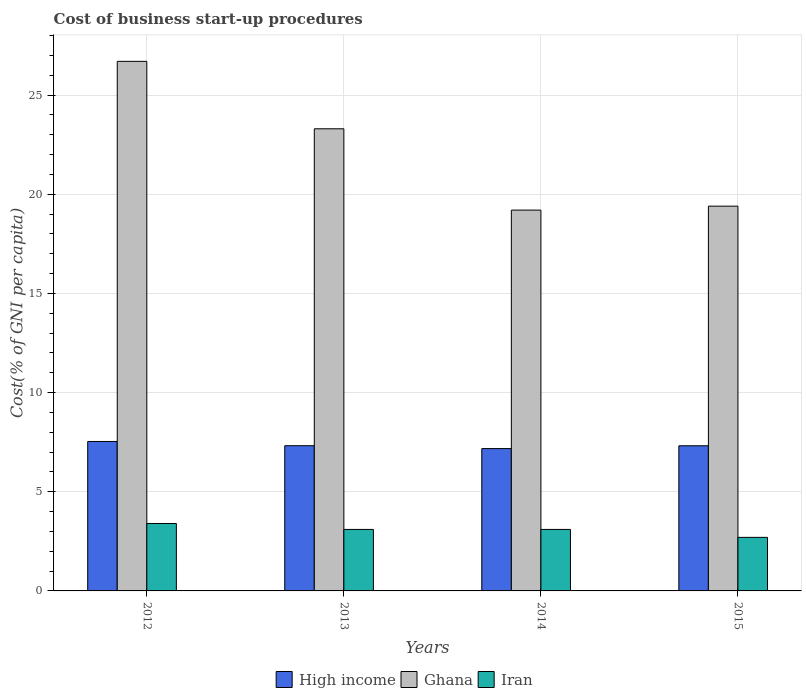How many groups of bars are there?
Offer a terse response. 4. Are the number of bars per tick equal to the number of legend labels?
Provide a short and direct response. Yes. Are the number of bars on each tick of the X-axis equal?
Provide a short and direct response. Yes. How many bars are there on the 3rd tick from the right?
Provide a succinct answer. 3. In how many cases, is the number of bars for a given year not equal to the number of legend labels?
Make the answer very short. 0. Across all years, what is the maximum cost of business start-up procedures in Ghana?
Make the answer very short. 26.7. Across all years, what is the minimum cost of business start-up procedures in Ghana?
Provide a succinct answer. 19.2. In which year was the cost of business start-up procedures in Iran minimum?
Provide a short and direct response. 2015. What is the total cost of business start-up procedures in High income in the graph?
Make the answer very short. 29.35. What is the difference between the cost of business start-up procedures in Iran in 2012 and that in 2013?
Offer a very short reply. 0.3. What is the difference between the cost of business start-up procedures in Iran in 2015 and the cost of business start-up procedures in High income in 2013?
Your answer should be very brief. -4.62. What is the average cost of business start-up procedures in High income per year?
Offer a very short reply. 7.34. In the year 2012, what is the difference between the cost of business start-up procedures in High income and cost of business start-up procedures in Iran?
Provide a succinct answer. 4.14. In how many years, is the cost of business start-up procedures in High income greater than 18 %?
Offer a very short reply. 0. What is the ratio of the cost of business start-up procedures in High income in 2014 to that in 2015?
Provide a succinct answer. 0.98. Is the difference between the cost of business start-up procedures in High income in 2012 and 2013 greater than the difference between the cost of business start-up procedures in Iran in 2012 and 2013?
Ensure brevity in your answer.  No. What is the difference between the highest and the second highest cost of business start-up procedures in High income?
Make the answer very short. 0.21. What is the difference between the highest and the lowest cost of business start-up procedures in Iran?
Your response must be concise. 0.7. Is the sum of the cost of business start-up procedures in Iran in 2014 and 2015 greater than the maximum cost of business start-up procedures in High income across all years?
Offer a very short reply. No. What does the 2nd bar from the left in 2012 represents?
Keep it short and to the point. Ghana. What does the 3rd bar from the right in 2012 represents?
Make the answer very short. High income. Are the values on the major ticks of Y-axis written in scientific E-notation?
Ensure brevity in your answer.  No. Does the graph contain any zero values?
Ensure brevity in your answer.  No. Does the graph contain grids?
Ensure brevity in your answer.  Yes. Where does the legend appear in the graph?
Offer a terse response. Bottom center. How are the legend labels stacked?
Give a very brief answer. Horizontal. What is the title of the graph?
Your response must be concise. Cost of business start-up procedures. Does "Dominican Republic" appear as one of the legend labels in the graph?
Your response must be concise. No. What is the label or title of the Y-axis?
Make the answer very short. Cost(% of GNI per capita). What is the Cost(% of GNI per capita) of High income in 2012?
Your answer should be compact. 7.54. What is the Cost(% of GNI per capita) in Ghana in 2012?
Offer a very short reply. 26.7. What is the Cost(% of GNI per capita) of High income in 2013?
Make the answer very short. 7.32. What is the Cost(% of GNI per capita) in Ghana in 2013?
Offer a terse response. 23.3. What is the Cost(% of GNI per capita) in Iran in 2013?
Ensure brevity in your answer.  3.1. What is the Cost(% of GNI per capita) of High income in 2014?
Provide a succinct answer. 7.18. What is the Cost(% of GNI per capita) in Ghana in 2014?
Provide a succinct answer. 19.2. What is the Cost(% of GNI per capita) of High income in 2015?
Your answer should be compact. 7.32. What is the Cost(% of GNI per capita) in Ghana in 2015?
Your answer should be compact. 19.4. Across all years, what is the maximum Cost(% of GNI per capita) of High income?
Provide a short and direct response. 7.54. Across all years, what is the maximum Cost(% of GNI per capita) of Ghana?
Give a very brief answer. 26.7. Across all years, what is the minimum Cost(% of GNI per capita) of High income?
Make the answer very short. 7.18. What is the total Cost(% of GNI per capita) of High income in the graph?
Keep it short and to the point. 29.35. What is the total Cost(% of GNI per capita) of Ghana in the graph?
Ensure brevity in your answer.  88.6. What is the total Cost(% of GNI per capita) in Iran in the graph?
Offer a very short reply. 12.3. What is the difference between the Cost(% of GNI per capita) in High income in 2012 and that in 2013?
Your answer should be compact. 0.21. What is the difference between the Cost(% of GNI per capita) in Ghana in 2012 and that in 2013?
Provide a short and direct response. 3.4. What is the difference between the Cost(% of GNI per capita) of High income in 2012 and that in 2014?
Provide a short and direct response. 0.36. What is the difference between the Cost(% of GNI per capita) of Ghana in 2012 and that in 2014?
Your response must be concise. 7.5. What is the difference between the Cost(% of GNI per capita) in High income in 2012 and that in 2015?
Your answer should be very brief. 0.22. What is the difference between the Cost(% of GNI per capita) in Ghana in 2012 and that in 2015?
Ensure brevity in your answer.  7.3. What is the difference between the Cost(% of GNI per capita) in High income in 2013 and that in 2014?
Your response must be concise. 0.14. What is the difference between the Cost(% of GNI per capita) in Iran in 2013 and that in 2014?
Provide a short and direct response. 0. What is the difference between the Cost(% of GNI per capita) of High income in 2013 and that in 2015?
Ensure brevity in your answer.  0. What is the difference between the Cost(% of GNI per capita) in Iran in 2013 and that in 2015?
Provide a succinct answer. 0.4. What is the difference between the Cost(% of GNI per capita) of High income in 2014 and that in 2015?
Provide a succinct answer. -0.14. What is the difference between the Cost(% of GNI per capita) in Iran in 2014 and that in 2015?
Keep it short and to the point. 0.4. What is the difference between the Cost(% of GNI per capita) in High income in 2012 and the Cost(% of GNI per capita) in Ghana in 2013?
Make the answer very short. -15.76. What is the difference between the Cost(% of GNI per capita) of High income in 2012 and the Cost(% of GNI per capita) of Iran in 2013?
Your answer should be compact. 4.44. What is the difference between the Cost(% of GNI per capita) in Ghana in 2012 and the Cost(% of GNI per capita) in Iran in 2013?
Keep it short and to the point. 23.6. What is the difference between the Cost(% of GNI per capita) of High income in 2012 and the Cost(% of GNI per capita) of Ghana in 2014?
Ensure brevity in your answer.  -11.66. What is the difference between the Cost(% of GNI per capita) of High income in 2012 and the Cost(% of GNI per capita) of Iran in 2014?
Offer a very short reply. 4.44. What is the difference between the Cost(% of GNI per capita) in Ghana in 2012 and the Cost(% of GNI per capita) in Iran in 2014?
Give a very brief answer. 23.6. What is the difference between the Cost(% of GNI per capita) of High income in 2012 and the Cost(% of GNI per capita) of Ghana in 2015?
Your answer should be very brief. -11.86. What is the difference between the Cost(% of GNI per capita) in High income in 2012 and the Cost(% of GNI per capita) in Iran in 2015?
Make the answer very short. 4.84. What is the difference between the Cost(% of GNI per capita) of Ghana in 2012 and the Cost(% of GNI per capita) of Iran in 2015?
Your answer should be very brief. 24. What is the difference between the Cost(% of GNI per capita) in High income in 2013 and the Cost(% of GNI per capita) in Ghana in 2014?
Provide a short and direct response. -11.88. What is the difference between the Cost(% of GNI per capita) of High income in 2013 and the Cost(% of GNI per capita) of Iran in 2014?
Give a very brief answer. 4.22. What is the difference between the Cost(% of GNI per capita) in Ghana in 2013 and the Cost(% of GNI per capita) in Iran in 2014?
Ensure brevity in your answer.  20.2. What is the difference between the Cost(% of GNI per capita) of High income in 2013 and the Cost(% of GNI per capita) of Ghana in 2015?
Your answer should be very brief. -12.08. What is the difference between the Cost(% of GNI per capita) of High income in 2013 and the Cost(% of GNI per capita) of Iran in 2015?
Offer a very short reply. 4.62. What is the difference between the Cost(% of GNI per capita) of Ghana in 2013 and the Cost(% of GNI per capita) of Iran in 2015?
Your answer should be very brief. 20.6. What is the difference between the Cost(% of GNI per capita) in High income in 2014 and the Cost(% of GNI per capita) in Ghana in 2015?
Offer a terse response. -12.22. What is the difference between the Cost(% of GNI per capita) of High income in 2014 and the Cost(% of GNI per capita) of Iran in 2015?
Offer a terse response. 4.48. What is the difference between the Cost(% of GNI per capita) of Ghana in 2014 and the Cost(% of GNI per capita) of Iran in 2015?
Your response must be concise. 16.5. What is the average Cost(% of GNI per capita) in High income per year?
Give a very brief answer. 7.34. What is the average Cost(% of GNI per capita) in Ghana per year?
Provide a short and direct response. 22.15. What is the average Cost(% of GNI per capita) in Iran per year?
Give a very brief answer. 3.08. In the year 2012, what is the difference between the Cost(% of GNI per capita) of High income and Cost(% of GNI per capita) of Ghana?
Your answer should be compact. -19.16. In the year 2012, what is the difference between the Cost(% of GNI per capita) of High income and Cost(% of GNI per capita) of Iran?
Ensure brevity in your answer.  4.14. In the year 2012, what is the difference between the Cost(% of GNI per capita) in Ghana and Cost(% of GNI per capita) in Iran?
Give a very brief answer. 23.3. In the year 2013, what is the difference between the Cost(% of GNI per capita) of High income and Cost(% of GNI per capita) of Ghana?
Provide a succinct answer. -15.98. In the year 2013, what is the difference between the Cost(% of GNI per capita) in High income and Cost(% of GNI per capita) in Iran?
Your answer should be very brief. 4.22. In the year 2013, what is the difference between the Cost(% of GNI per capita) of Ghana and Cost(% of GNI per capita) of Iran?
Your response must be concise. 20.2. In the year 2014, what is the difference between the Cost(% of GNI per capita) in High income and Cost(% of GNI per capita) in Ghana?
Give a very brief answer. -12.02. In the year 2014, what is the difference between the Cost(% of GNI per capita) in High income and Cost(% of GNI per capita) in Iran?
Ensure brevity in your answer.  4.08. In the year 2014, what is the difference between the Cost(% of GNI per capita) of Ghana and Cost(% of GNI per capita) of Iran?
Offer a terse response. 16.1. In the year 2015, what is the difference between the Cost(% of GNI per capita) of High income and Cost(% of GNI per capita) of Ghana?
Offer a very short reply. -12.08. In the year 2015, what is the difference between the Cost(% of GNI per capita) in High income and Cost(% of GNI per capita) in Iran?
Provide a short and direct response. 4.62. In the year 2015, what is the difference between the Cost(% of GNI per capita) of Ghana and Cost(% of GNI per capita) of Iran?
Offer a terse response. 16.7. What is the ratio of the Cost(% of GNI per capita) in High income in 2012 to that in 2013?
Offer a terse response. 1.03. What is the ratio of the Cost(% of GNI per capita) in Ghana in 2012 to that in 2013?
Your answer should be very brief. 1.15. What is the ratio of the Cost(% of GNI per capita) in Iran in 2012 to that in 2013?
Your answer should be very brief. 1.1. What is the ratio of the Cost(% of GNI per capita) in High income in 2012 to that in 2014?
Offer a very short reply. 1.05. What is the ratio of the Cost(% of GNI per capita) in Ghana in 2012 to that in 2014?
Give a very brief answer. 1.39. What is the ratio of the Cost(% of GNI per capita) in Iran in 2012 to that in 2014?
Make the answer very short. 1.1. What is the ratio of the Cost(% of GNI per capita) of High income in 2012 to that in 2015?
Ensure brevity in your answer.  1.03. What is the ratio of the Cost(% of GNI per capita) in Ghana in 2012 to that in 2015?
Keep it short and to the point. 1.38. What is the ratio of the Cost(% of GNI per capita) of Iran in 2012 to that in 2015?
Provide a short and direct response. 1.26. What is the ratio of the Cost(% of GNI per capita) of High income in 2013 to that in 2014?
Your response must be concise. 1.02. What is the ratio of the Cost(% of GNI per capita) in Ghana in 2013 to that in 2014?
Provide a short and direct response. 1.21. What is the ratio of the Cost(% of GNI per capita) in High income in 2013 to that in 2015?
Give a very brief answer. 1. What is the ratio of the Cost(% of GNI per capita) in Ghana in 2013 to that in 2015?
Offer a terse response. 1.2. What is the ratio of the Cost(% of GNI per capita) of Iran in 2013 to that in 2015?
Keep it short and to the point. 1.15. What is the ratio of the Cost(% of GNI per capita) of High income in 2014 to that in 2015?
Your answer should be compact. 0.98. What is the ratio of the Cost(% of GNI per capita) in Ghana in 2014 to that in 2015?
Offer a very short reply. 0.99. What is the ratio of the Cost(% of GNI per capita) of Iran in 2014 to that in 2015?
Give a very brief answer. 1.15. What is the difference between the highest and the second highest Cost(% of GNI per capita) in High income?
Your answer should be very brief. 0.21. What is the difference between the highest and the second highest Cost(% of GNI per capita) in Ghana?
Offer a very short reply. 3.4. What is the difference between the highest and the second highest Cost(% of GNI per capita) of Iran?
Give a very brief answer. 0.3. What is the difference between the highest and the lowest Cost(% of GNI per capita) in High income?
Make the answer very short. 0.36. What is the difference between the highest and the lowest Cost(% of GNI per capita) of Iran?
Make the answer very short. 0.7. 